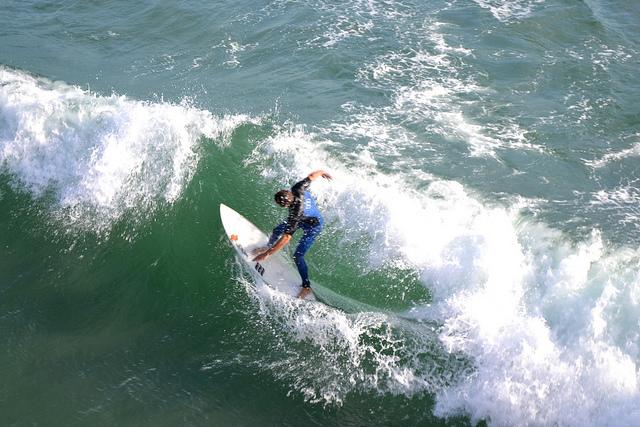What color is the womens wetsuit?
Write a very short answer. Blue. What color is the persons wetsuit?
Quick response, please. Blue. What color is the surfboard?
Short answer required. White. Is the water calm?
Answer briefly. No. What is this man standing on?
Short answer required. Surfboard. Is this man wearing a watch?
Answer briefly. No. 